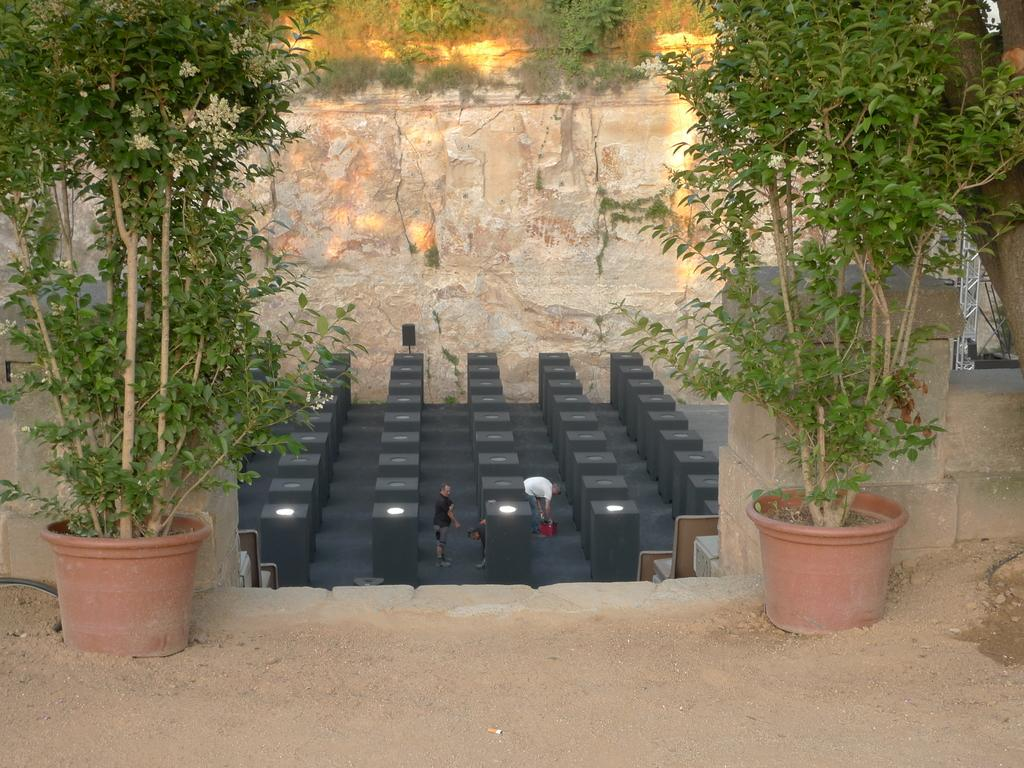What is the primary setting of the image? The primary setting of the image is the ground, where people are standing. What type of vegetation is present in the image? There are plants in pots in the image. What type of cheese is being served by the mom in the image? There is no mom or cheese present in the image. Is the crook trying to steal the plants in the image? There is no crook present in the image, so it is not possible to determine if they are trying to steal the plants. 